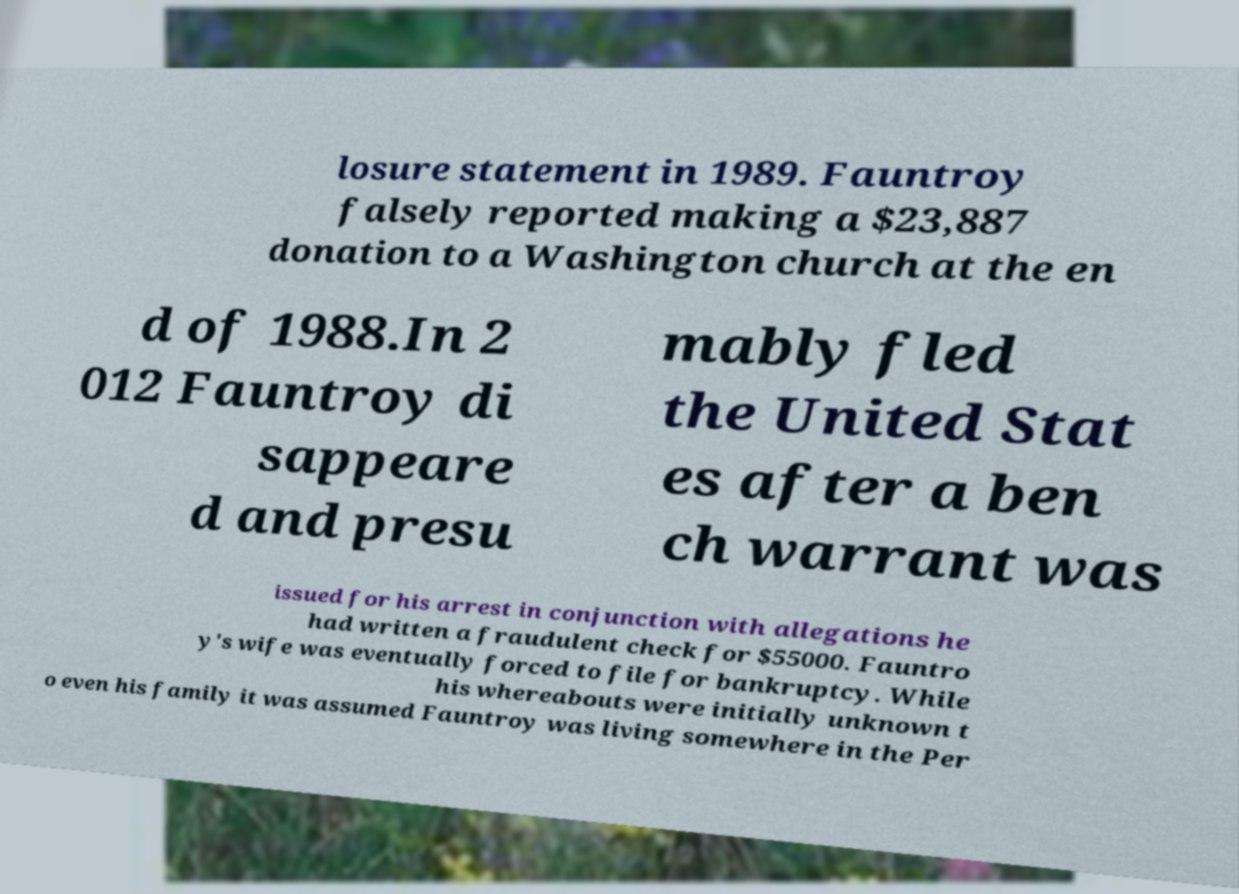For documentation purposes, I need the text within this image transcribed. Could you provide that? losure statement in 1989. Fauntroy falsely reported making a $23,887 donation to a Washington church at the en d of 1988.In 2 012 Fauntroy di sappeare d and presu mably fled the United Stat es after a ben ch warrant was issued for his arrest in conjunction with allegations he had written a fraudulent check for $55000. Fauntro y's wife was eventually forced to file for bankruptcy. While his whereabouts were initially unknown t o even his family it was assumed Fauntroy was living somewhere in the Per 